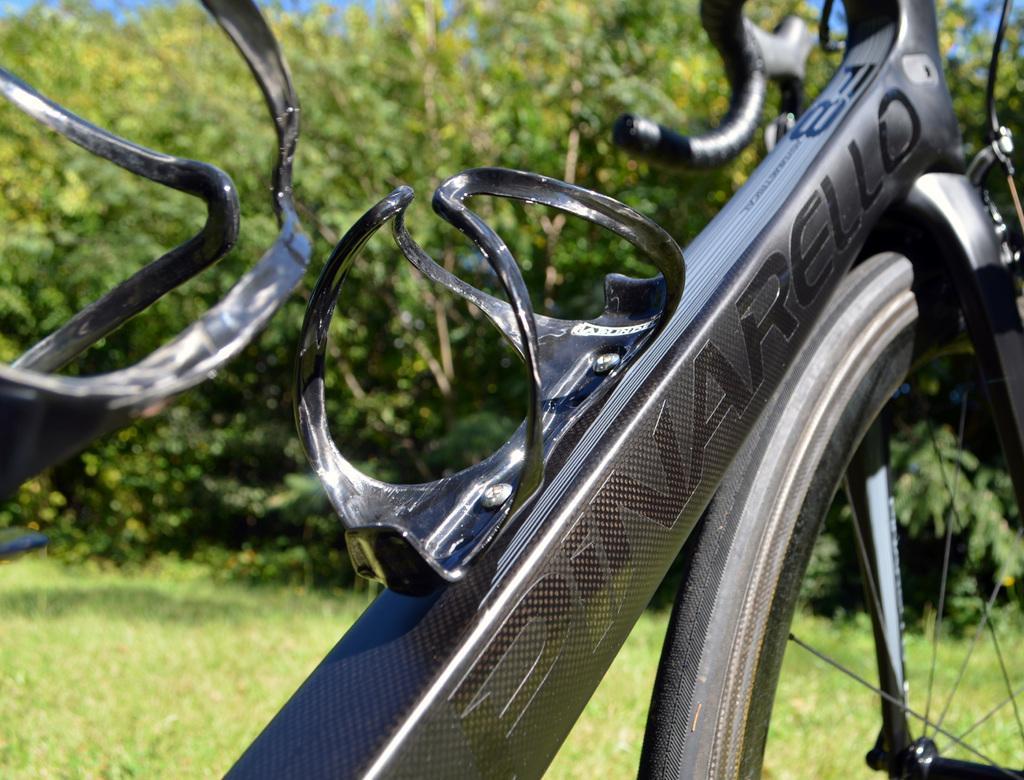Describe this image in one or two sentences. In the picture I can see a black color bicycle which has something written on it. In the background I can see trees and grass. The background of the image is blurred. 